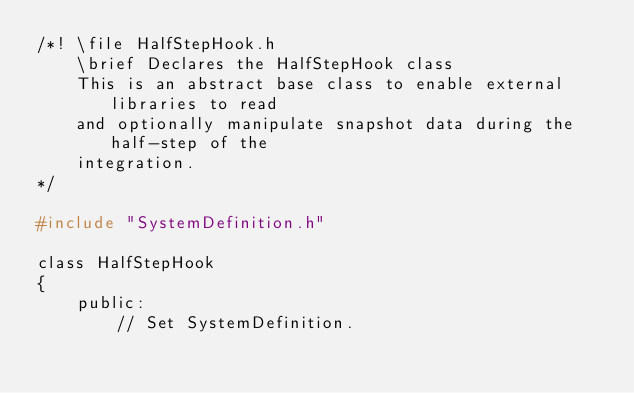Convert code to text. <code><loc_0><loc_0><loc_500><loc_500><_C_>/*! \file HalfStepHook.h
    \brief Declares the HalfStepHook class
    This is an abstract base class to enable external libraries to read
    and optionally manipulate snapshot data during the half-step of the
    integration.
*/

#include "SystemDefinition.h"

class HalfStepHook
{
    public:
        // Set SystemDefinition.</code> 